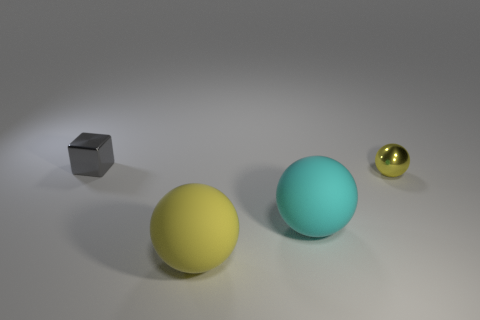What is the size of the yellow shiny thing that is the same shape as the big yellow rubber thing?
Your answer should be compact. Small. Is there anything else that has the same material as the cube?
Your response must be concise. Yes. Is the size of the yellow object that is behind the big yellow rubber ball the same as the yellow rubber sphere to the right of the small block?
Keep it short and to the point. No. How many big things are yellow metal objects or gray things?
Ensure brevity in your answer.  0. How many yellow spheres are both in front of the cyan rubber ball and behind the cyan matte thing?
Ensure brevity in your answer.  0. Is the big yellow sphere made of the same material as the gray object that is to the left of the yellow metallic thing?
Offer a terse response. No. How many gray things are either tiny cubes or small metallic balls?
Make the answer very short. 1. Are there any other gray metallic cubes of the same size as the gray cube?
Your response must be concise. No. There is a big thing behind the big yellow matte thing in front of the tiny thing on the left side of the yellow shiny ball; what is its material?
Keep it short and to the point. Rubber. Are there the same number of tiny metal things that are right of the gray cube and small blue metallic cylinders?
Provide a short and direct response. No. 